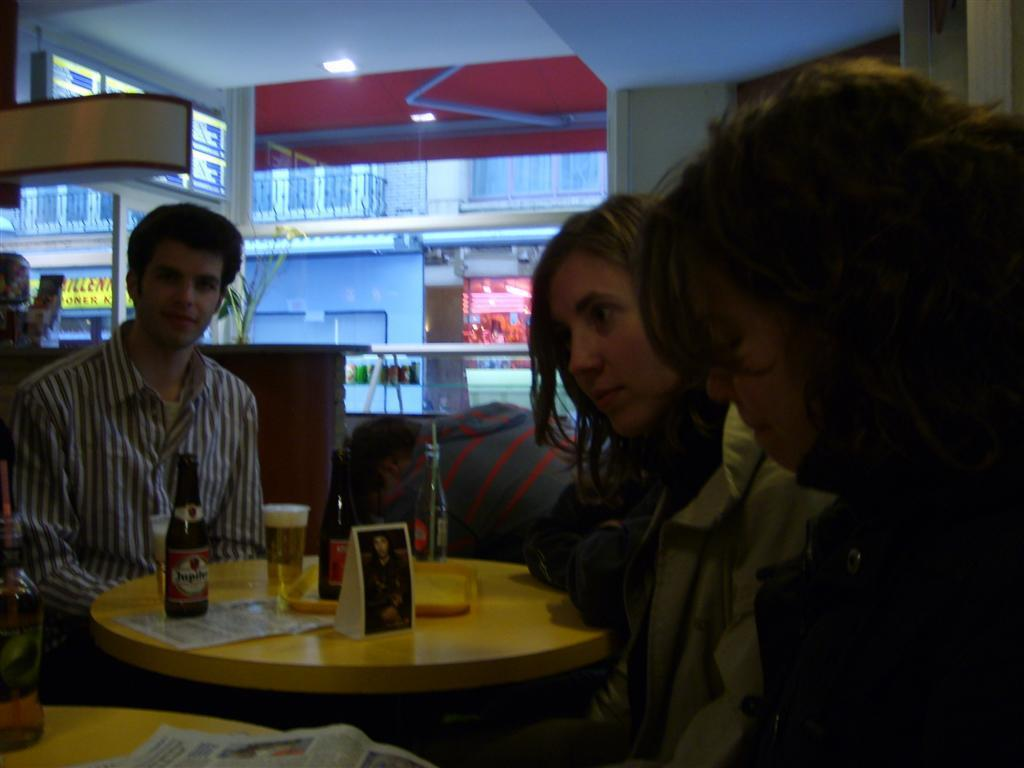How many people are in the image? There is a group of people in the image. What are the people doing in the image? The people are sitting in chairs. Where are the chairs located in relation to the table? The chairs are near a table. What items can be seen on the table? There is a glass, a bottle, and a photo on the table. What can be seen in the background of the image? There is a building and a light in the background of the image. Is there an oven visible in the image? No, there is no oven present in the image. Can you see a car in the background of the image? No, there is no car visible in the image; only a building and a light can be seen in the background. 